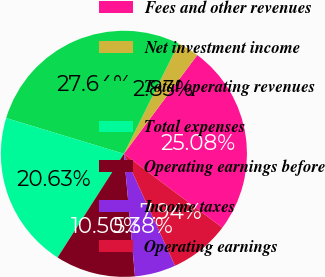<chart> <loc_0><loc_0><loc_500><loc_500><pie_chart><fcel>Fees and other revenues<fcel>Net investment income<fcel>Total operating revenues<fcel>Total expenses<fcel>Operating earnings before<fcel>Income taxes<fcel>Operating earnings<nl><fcel>25.08%<fcel>2.83%<fcel>27.64%<fcel>20.63%<fcel>10.5%<fcel>5.38%<fcel>7.94%<nl></chart> 